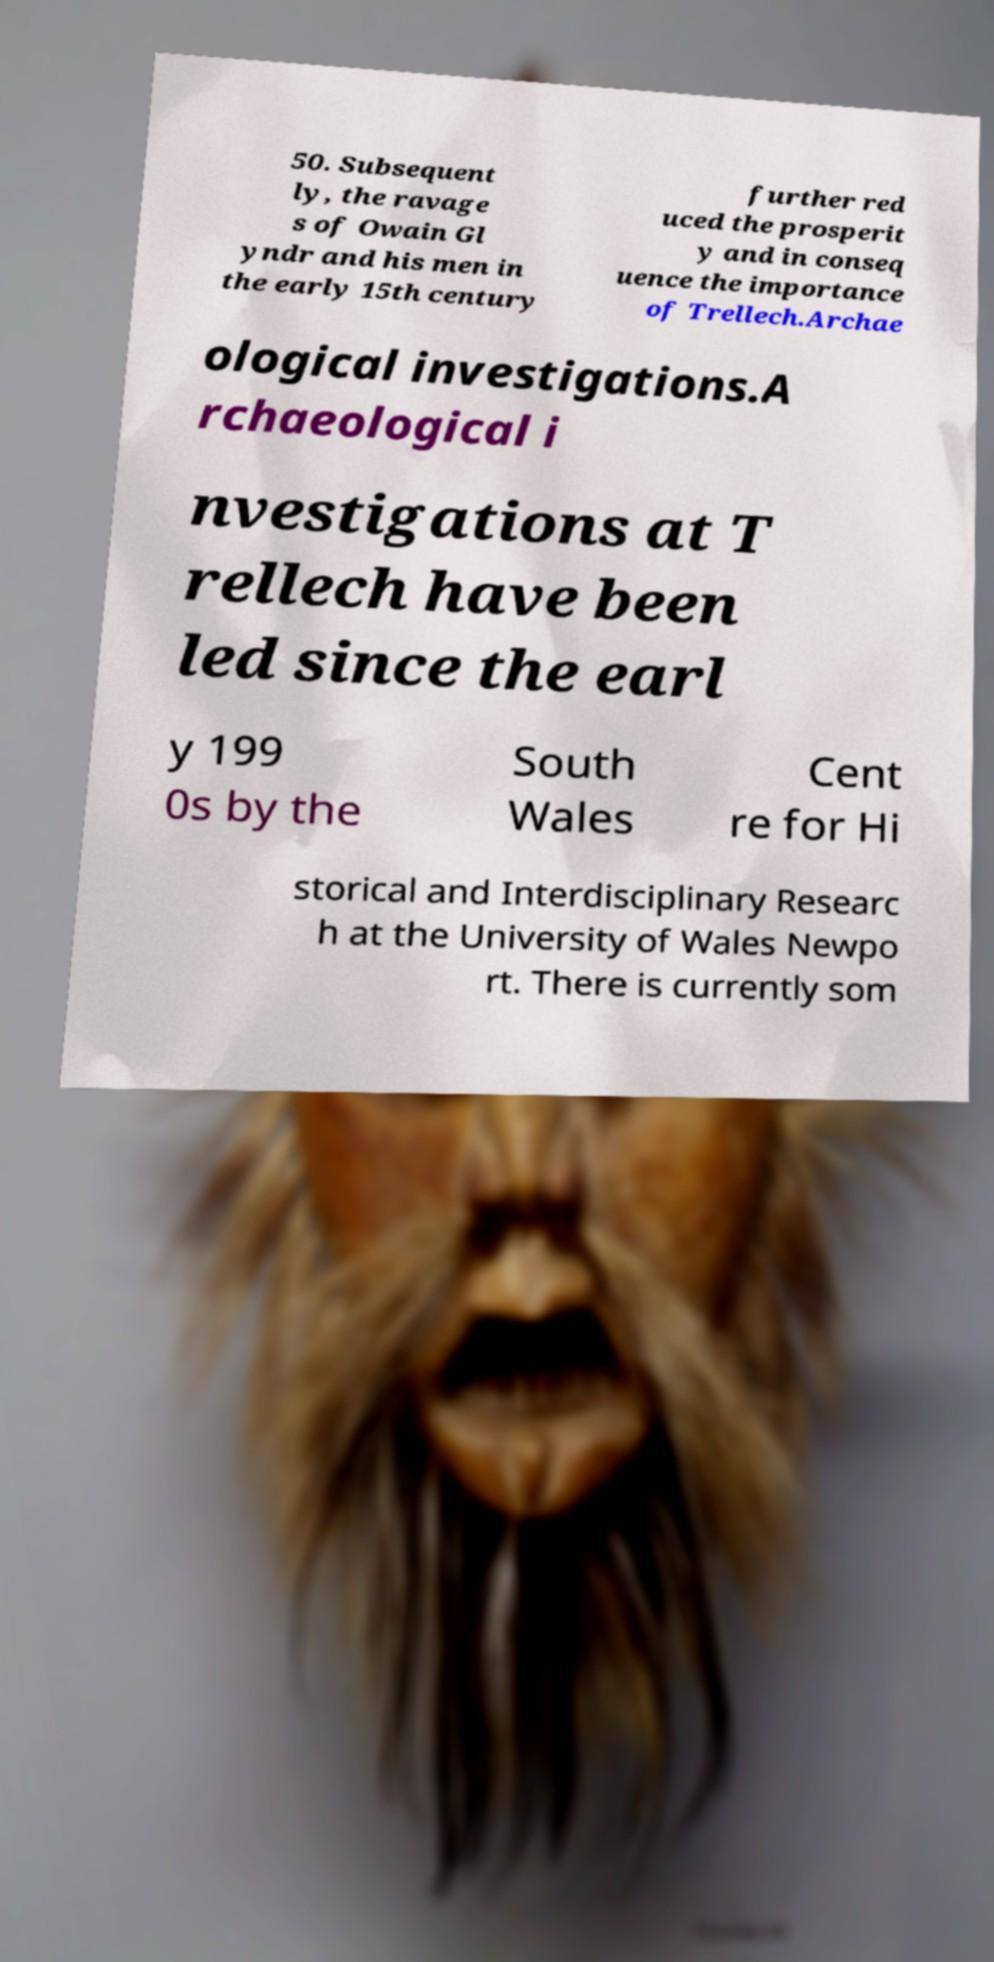What messages or text are displayed in this image? I need them in a readable, typed format. 50. Subsequent ly, the ravage s of Owain Gl yndr and his men in the early 15th century further red uced the prosperit y and in conseq uence the importance of Trellech.Archae ological investigations.A rchaeological i nvestigations at T rellech have been led since the earl y 199 0s by the South Wales Cent re for Hi storical and Interdisciplinary Researc h at the University of Wales Newpo rt. There is currently som 